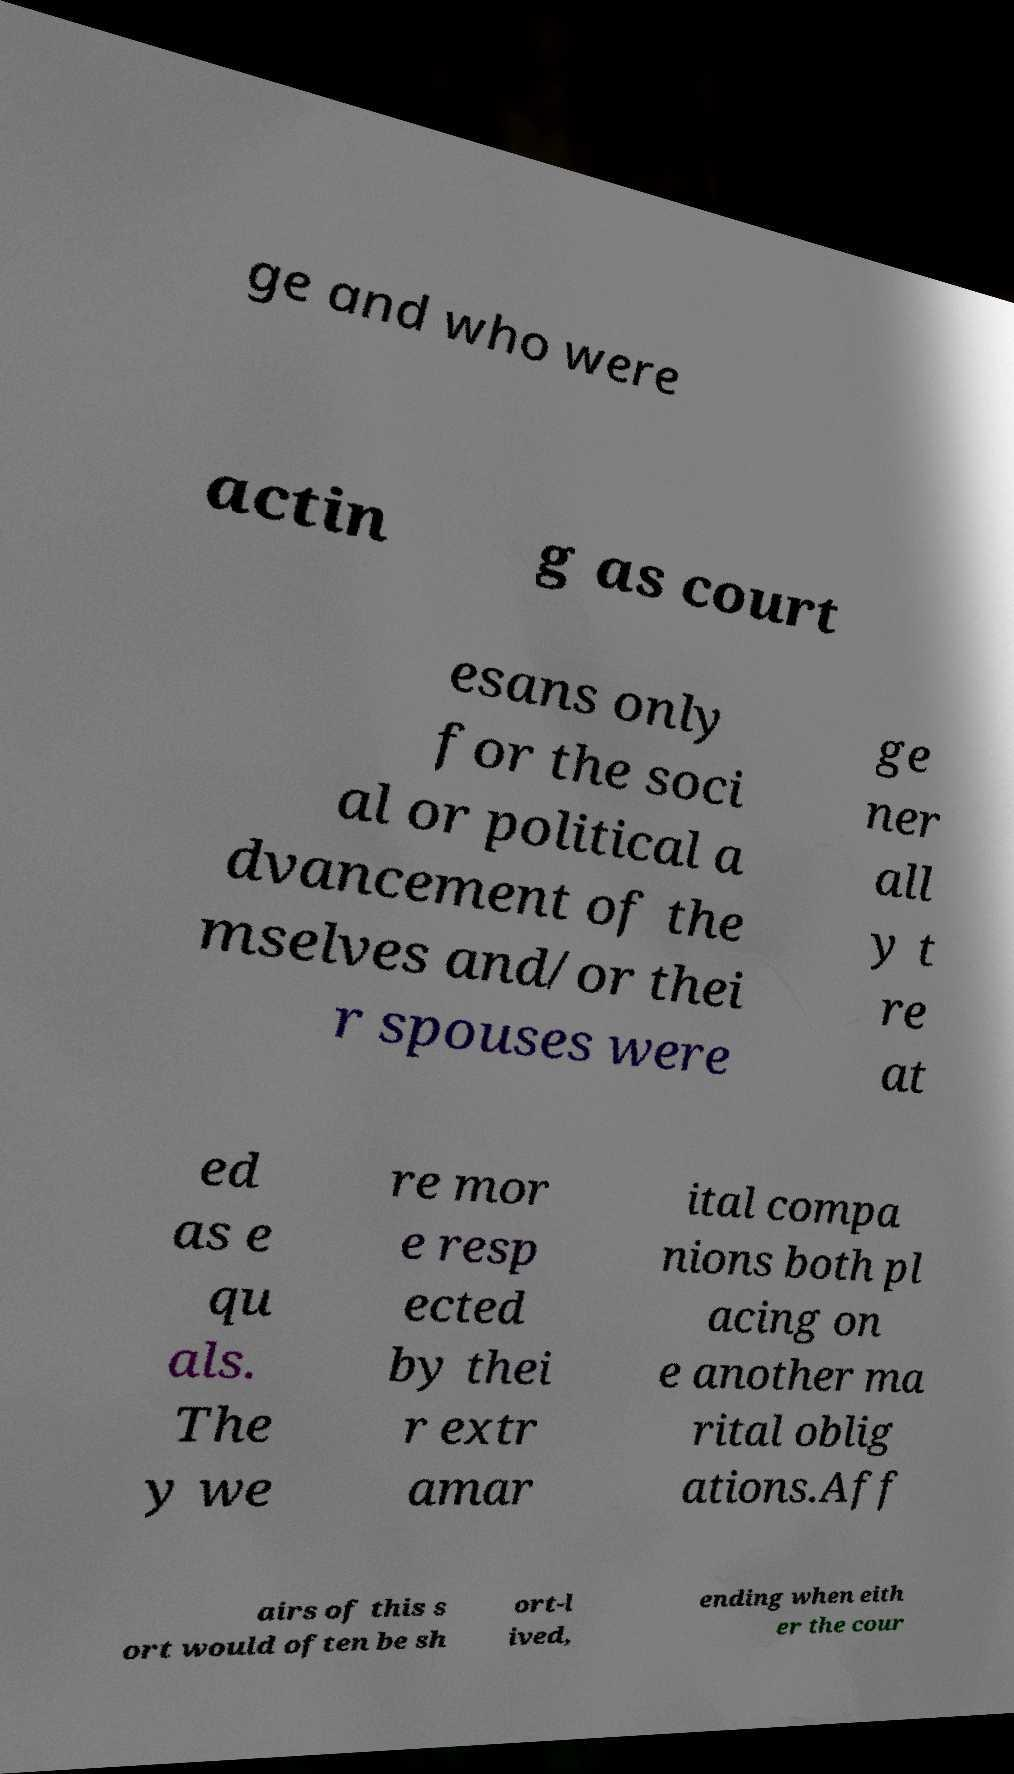Please read and relay the text visible in this image. What does it say? ge and who were actin g as court esans only for the soci al or political a dvancement of the mselves and/or thei r spouses were ge ner all y t re at ed as e qu als. The y we re mor e resp ected by thei r extr amar ital compa nions both pl acing on e another ma rital oblig ations.Aff airs of this s ort would often be sh ort-l ived, ending when eith er the cour 